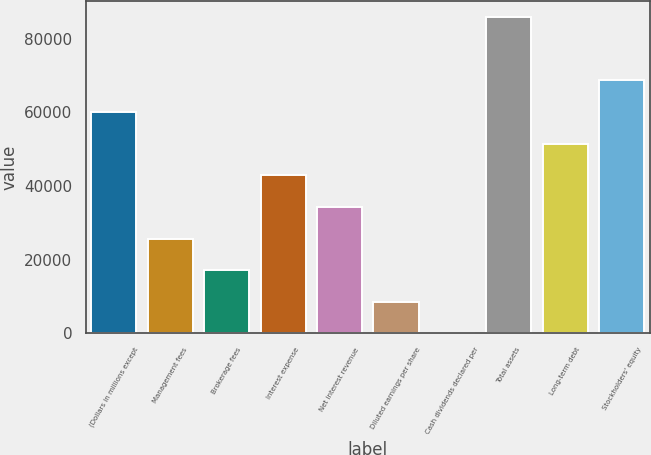Convert chart to OTSL. <chart><loc_0><loc_0><loc_500><loc_500><bar_chart><fcel>(Dollars in millions except<fcel>Management fees<fcel>Brokerage fees<fcel>Interest expense<fcel>Net interest revenue<fcel>Diluted earnings per share<fcel>Cash dividends declared per<fcel>Total assets<fcel>Long-term debt<fcel>Stockholders' equity<nl><fcel>60055.9<fcel>25738.5<fcel>17159.2<fcel>42897.2<fcel>34317.9<fcel>8579.83<fcel>0.48<fcel>85794<fcel>51476.6<fcel>68635.3<nl></chart> 